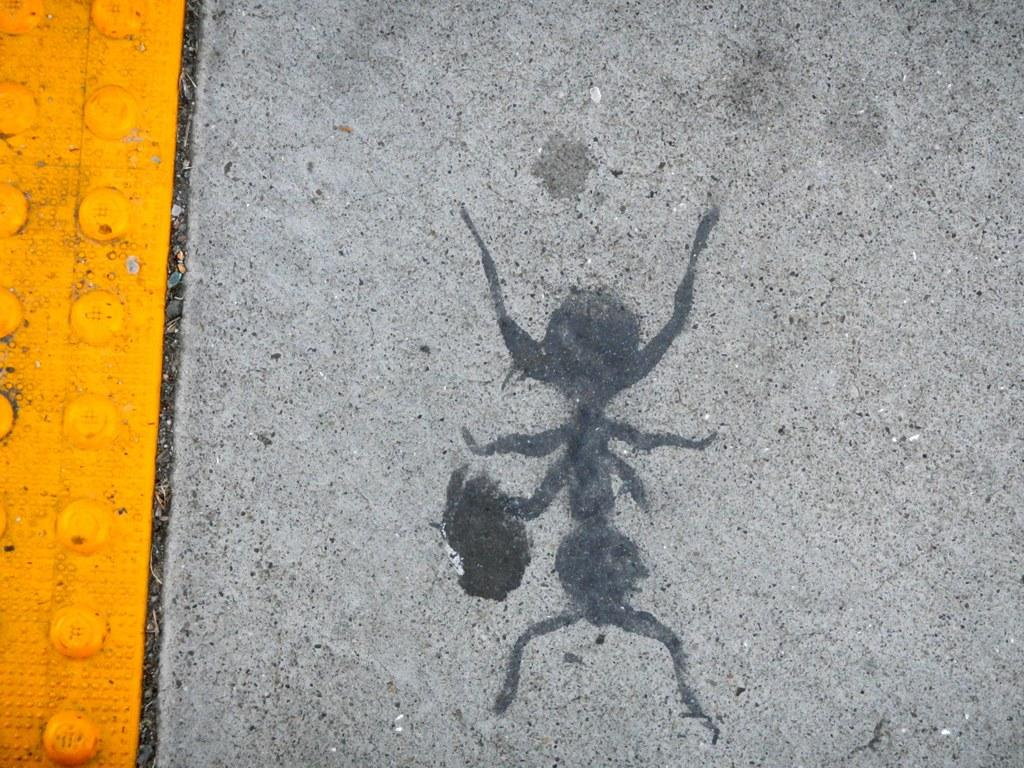What is the main subject of the image? There is an insect depicted in the image. What type of surface is the insect on? The insect is on a cement surface. What can be seen on the left side of the image? There is a tile on the left side of the image. What type of protest is taking place in the image? There is no protest present in the image; it features an insect on a cement surface and a tile on the left side. What type of creature is interacting with the substance in the image? There is no substance or creature interacting with it in the image; it only shows an insect on a cement surface and a tile on the left side. 